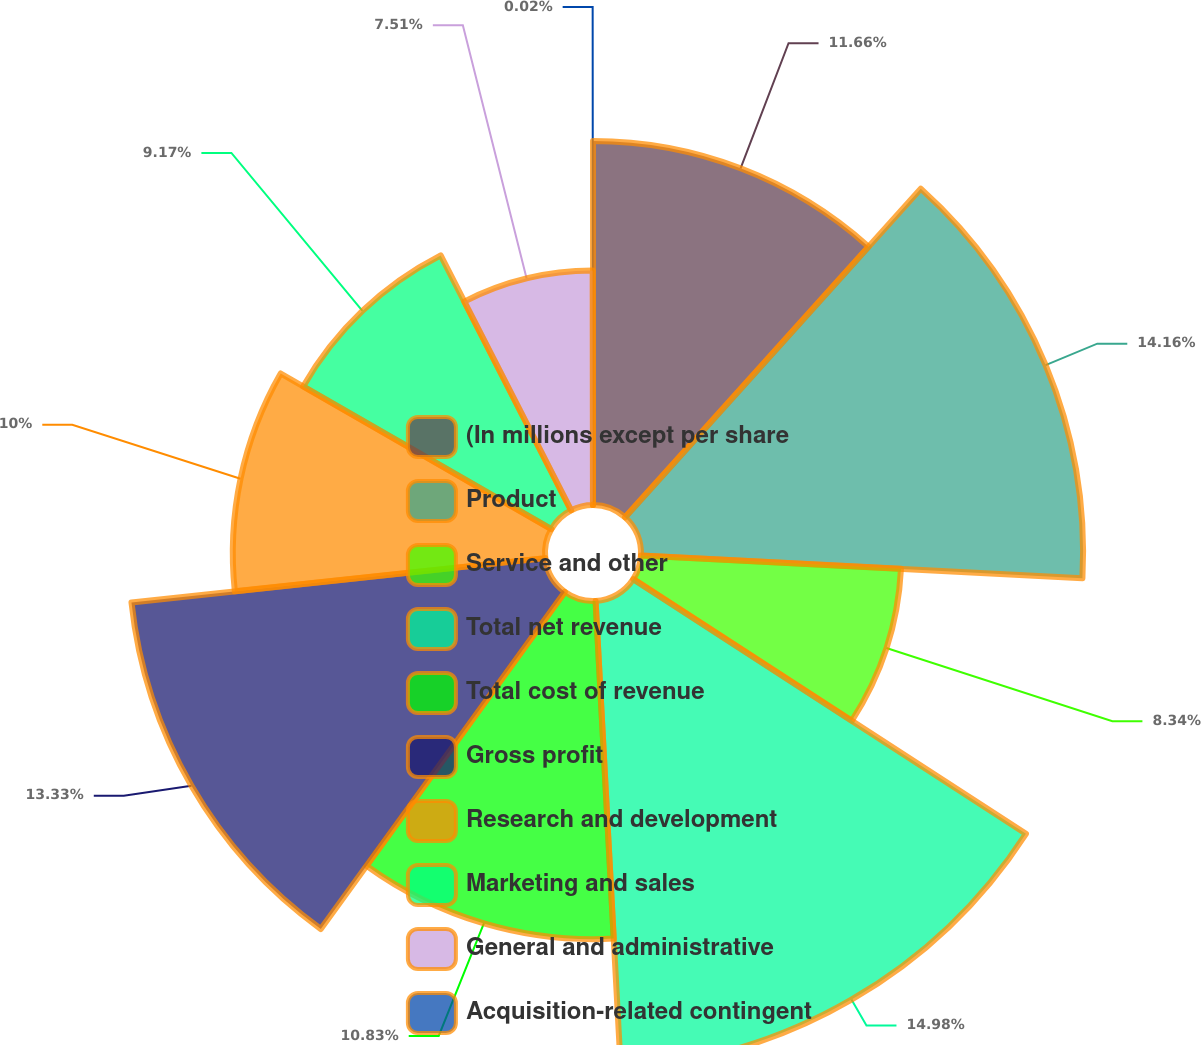<chart> <loc_0><loc_0><loc_500><loc_500><pie_chart><fcel>(In millions except per share<fcel>Product<fcel>Service and other<fcel>Total net revenue<fcel>Total cost of revenue<fcel>Gross profit<fcel>Research and development<fcel>Marketing and sales<fcel>General and administrative<fcel>Acquisition-related contingent<nl><fcel>11.66%<fcel>14.16%<fcel>8.34%<fcel>14.99%<fcel>10.83%<fcel>13.33%<fcel>10.0%<fcel>9.17%<fcel>7.51%<fcel>0.02%<nl></chart> 